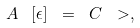<formula> <loc_0><loc_0><loc_500><loc_500>A \ \left [ \epsilon \right ] \ = \ C \ > ,</formula> 